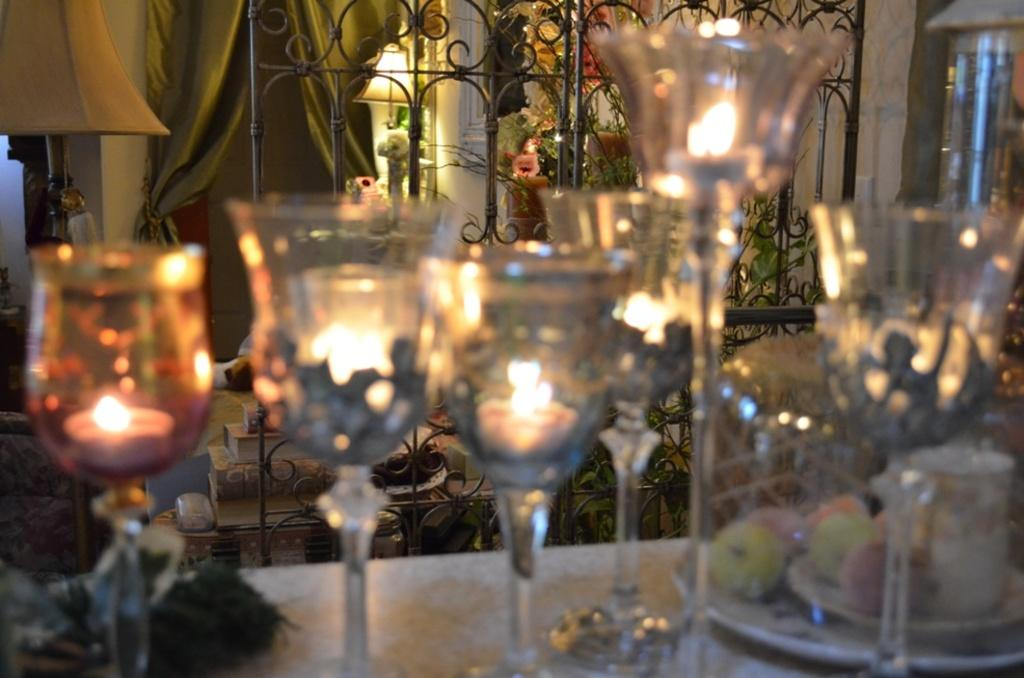What piece of furniture is in the image? There is a table in the image. What objects are on the table? There are glasses and candles on the table. What type of vegetation is visible in the image? There are plants visible in the image. What type of window treatment is present in the image? There are curtains in the image. How would you describe the image's clarity? The image is blurry in the front. What type of sponge can be seen in the image? There is no sponge present in the image. 